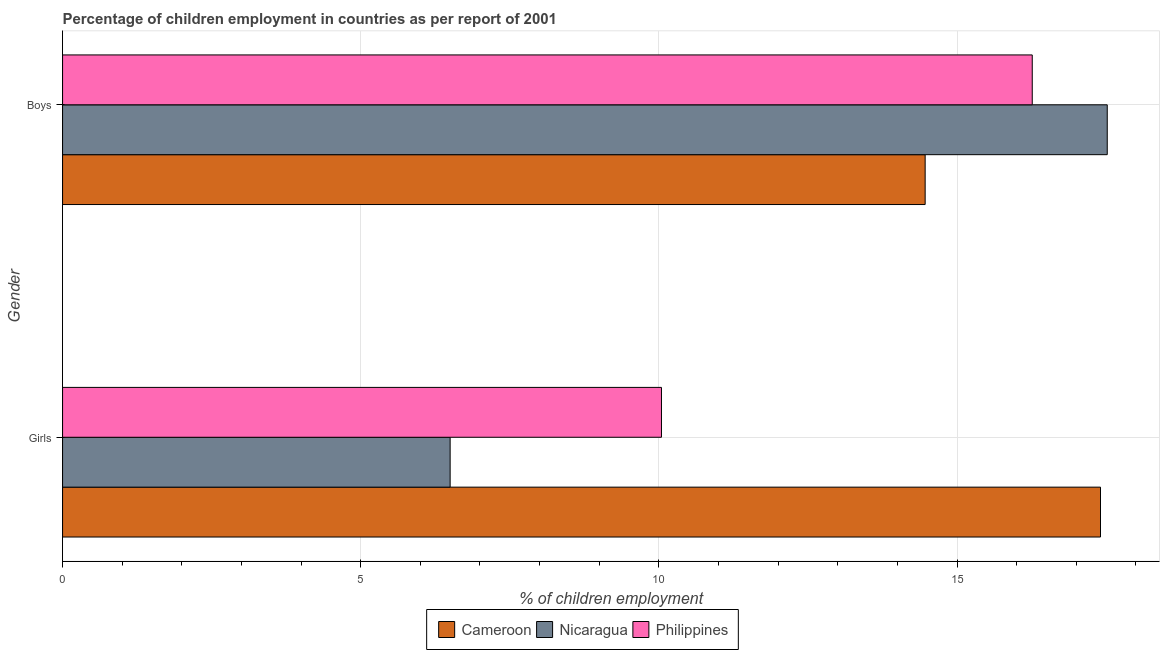How many bars are there on the 2nd tick from the bottom?
Keep it short and to the point. 3. What is the label of the 2nd group of bars from the top?
Your response must be concise. Girls. What is the percentage of employed girls in Cameroon?
Ensure brevity in your answer.  17.41. Across all countries, what is the maximum percentage of employed girls?
Your answer should be compact. 17.41. Across all countries, what is the minimum percentage of employed boys?
Offer a terse response. 14.47. In which country was the percentage of employed boys maximum?
Offer a terse response. Nicaragua. In which country was the percentage of employed boys minimum?
Provide a succinct answer. Cameroon. What is the total percentage of employed girls in the graph?
Offer a terse response. 33.95. What is the difference between the percentage of employed boys in Nicaragua and that in Philippines?
Provide a succinct answer. 1.26. What is the difference between the percentage of employed girls in Nicaragua and the percentage of employed boys in Philippines?
Keep it short and to the point. -9.76. What is the average percentage of employed girls per country?
Offer a very short reply. 11.32. What is the difference between the percentage of employed girls and percentage of employed boys in Nicaragua?
Offer a terse response. -11.02. What is the ratio of the percentage of employed girls in Philippines to that in Nicaragua?
Ensure brevity in your answer.  1.55. In how many countries, is the percentage of employed girls greater than the average percentage of employed girls taken over all countries?
Offer a very short reply. 1. What does the 1st bar from the top in Girls represents?
Make the answer very short. Philippines. What does the 1st bar from the bottom in Girls represents?
Ensure brevity in your answer.  Cameroon. Are the values on the major ticks of X-axis written in scientific E-notation?
Provide a short and direct response. No. Does the graph contain any zero values?
Your answer should be compact. No. What is the title of the graph?
Provide a succinct answer. Percentage of children employment in countries as per report of 2001. Does "Bahrain" appear as one of the legend labels in the graph?
Ensure brevity in your answer.  No. What is the label or title of the X-axis?
Keep it short and to the point. % of children employment. What is the label or title of the Y-axis?
Offer a terse response. Gender. What is the % of children employment of Cameroon in Girls?
Keep it short and to the point. 17.41. What is the % of children employment of Nicaragua in Girls?
Your answer should be very brief. 6.5. What is the % of children employment in Philippines in Girls?
Your answer should be compact. 10.04. What is the % of children employment in Cameroon in Boys?
Your answer should be compact. 14.47. What is the % of children employment in Nicaragua in Boys?
Make the answer very short. 17.52. What is the % of children employment in Philippines in Boys?
Your response must be concise. 16.26. Across all Gender, what is the maximum % of children employment in Cameroon?
Provide a succinct answer. 17.41. Across all Gender, what is the maximum % of children employment in Nicaragua?
Provide a succinct answer. 17.52. Across all Gender, what is the maximum % of children employment of Philippines?
Offer a terse response. 16.26. Across all Gender, what is the minimum % of children employment in Cameroon?
Your response must be concise. 14.47. Across all Gender, what is the minimum % of children employment of Nicaragua?
Provide a short and direct response. 6.5. Across all Gender, what is the minimum % of children employment in Philippines?
Provide a succinct answer. 10.04. What is the total % of children employment of Cameroon in the graph?
Provide a short and direct response. 31.87. What is the total % of children employment in Nicaragua in the graph?
Your response must be concise. 24.02. What is the total % of children employment of Philippines in the graph?
Make the answer very short. 26.31. What is the difference between the % of children employment in Cameroon in Girls and that in Boys?
Your answer should be very brief. 2.94. What is the difference between the % of children employment in Nicaragua in Girls and that in Boys?
Provide a short and direct response. -11.02. What is the difference between the % of children employment of Philippines in Girls and that in Boys?
Make the answer very short. -6.22. What is the difference between the % of children employment of Cameroon in Girls and the % of children employment of Nicaragua in Boys?
Your answer should be compact. -0.11. What is the difference between the % of children employment in Cameroon in Girls and the % of children employment in Philippines in Boys?
Your response must be concise. 1.14. What is the difference between the % of children employment in Nicaragua in Girls and the % of children employment in Philippines in Boys?
Make the answer very short. -9.76. What is the average % of children employment of Cameroon per Gender?
Offer a very short reply. 15.94. What is the average % of children employment in Nicaragua per Gender?
Your answer should be very brief. 12.01. What is the average % of children employment of Philippines per Gender?
Your response must be concise. 13.15. What is the difference between the % of children employment in Cameroon and % of children employment in Nicaragua in Girls?
Ensure brevity in your answer.  10.91. What is the difference between the % of children employment in Cameroon and % of children employment in Philippines in Girls?
Keep it short and to the point. 7.36. What is the difference between the % of children employment of Nicaragua and % of children employment of Philippines in Girls?
Provide a short and direct response. -3.54. What is the difference between the % of children employment in Cameroon and % of children employment in Nicaragua in Boys?
Your answer should be very brief. -3.05. What is the difference between the % of children employment in Cameroon and % of children employment in Philippines in Boys?
Provide a short and direct response. -1.8. What is the difference between the % of children employment of Nicaragua and % of children employment of Philippines in Boys?
Your response must be concise. 1.26. What is the ratio of the % of children employment of Cameroon in Girls to that in Boys?
Keep it short and to the point. 1.2. What is the ratio of the % of children employment in Nicaragua in Girls to that in Boys?
Offer a terse response. 0.37. What is the ratio of the % of children employment in Philippines in Girls to that in Boys?
Offer a terse response. 0.62. What is the difference between the highest and the second highest % of children employment in Cameroon?
Your answer should be very brief. 2.94. What is the difference between the highest and the second highest % of children employment of Nicaragua?
Ensure brevity in your answer.  11.02. What is the difference between the highest and the second highest % of children employment of Philippines?
Give a very brief answer. 6.22. What is the difference between the highest and the lowest % of children employment of Cameroon?
Give a very brief answer. 2.94. What is the difference between the highest and the lowest % of children employment in Nicaragua?
Your answer should be very brief. 11.02. What is the difference between the highest and the lowest % of children employment of Philippines?
Your answer should be compact. 6.22. 